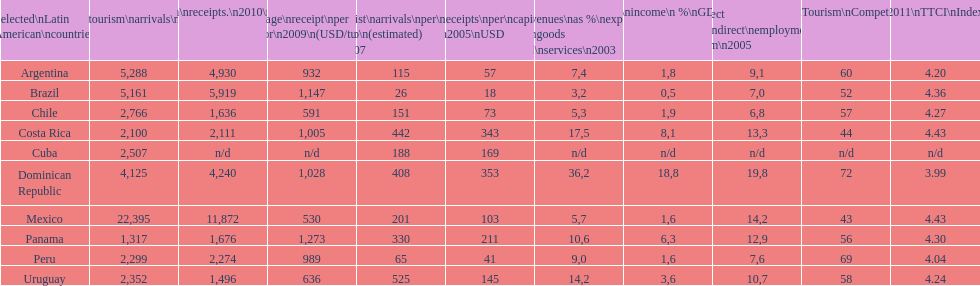Which latin american nation had the highest amount of tourist visits in 2010? Mexico. 